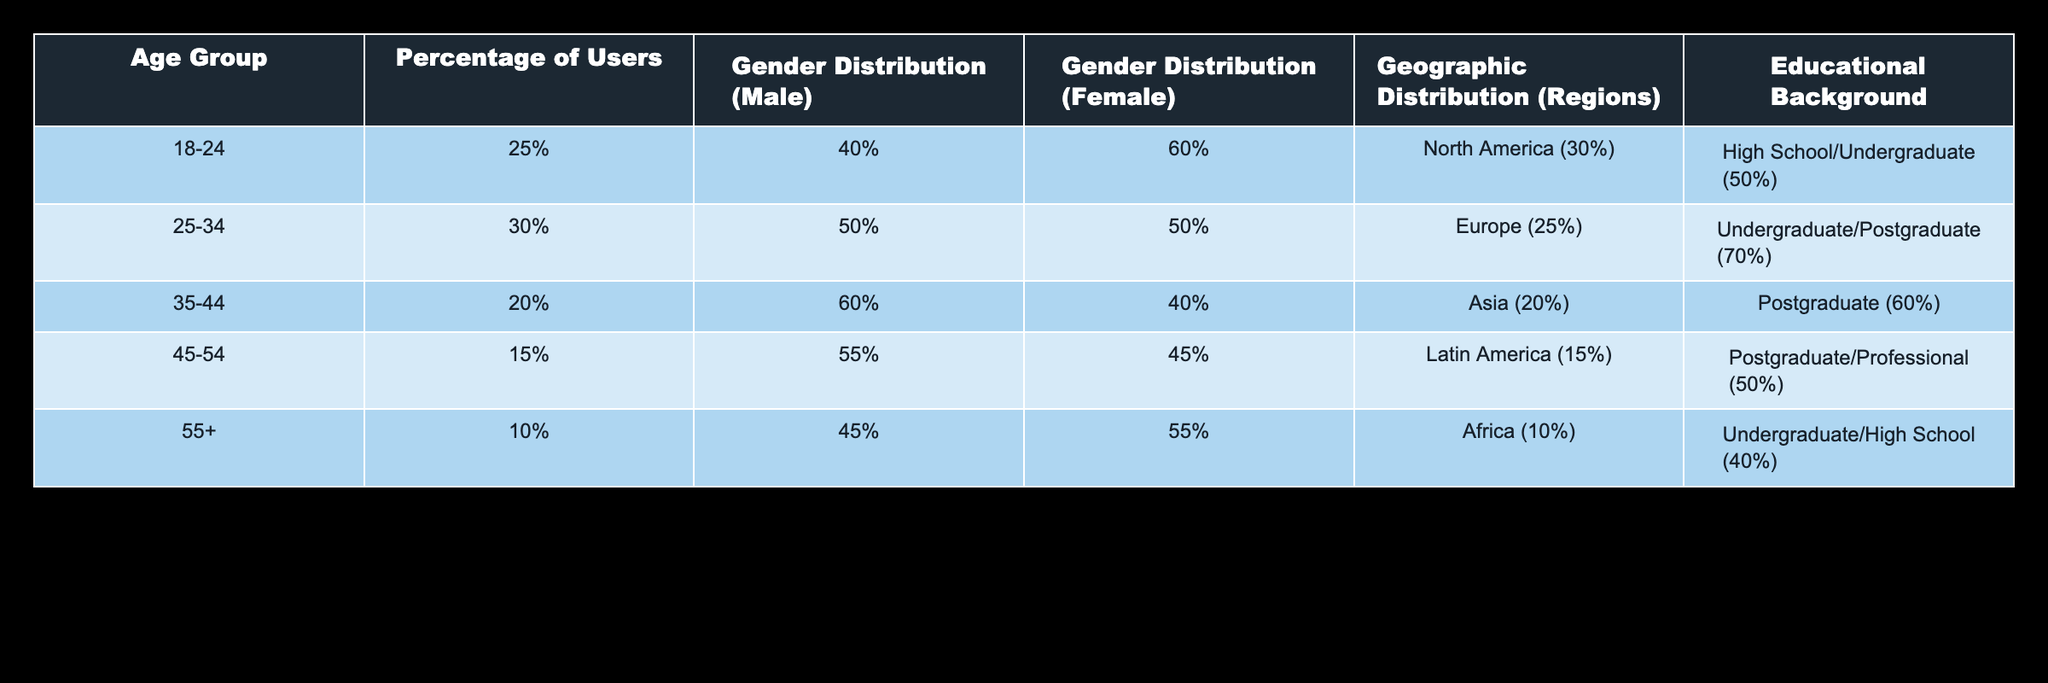What is the percentage of users aged 18-24? The table shows the "Percentage of Users" under the "Age Group" of 18-24 as 25%.
Answer: 25% Which gender has a higher distribution among users aged 45-54? The table lists the "Gender Distribution (Male)" as 55% and "Gender Distribution (Female)" as 45% for users aged 45-54, indicating that males have a higher distribution.
Answer: Male What is the educational background for the age group 35-44? The educational background for the age group 35-44 is listed as "Postgraduate (60%)", meaning that 60% of users in this age group have a postgraduate education.
Answer: Postgraduate Is the percentage of users aged 55+ greater than those aged 35-44? The percentage of users in the 55+ age group is 10%, while the percentage for the 35-44 age group is 20%. Since 10% is less than 20%, it is false that the percentage of users aged 55+ is greater than those aged 35-44.
Answer: No What is the combined percentage of users aged 25-34 and 35-44? The percentage of users 25-34 is 30%, and for 35-44 it is 20%. Adding them together (30 + 20) gives a total of 50%.
Answer: 50% Which geographic region has the highest percentage of users? According to the geographic distribution, North America is noted as having the highest percentage of users at 30%.
Answer: North America Do more users have an undergraduate background or a postgraduate background? For undergraduate backgrounds, the data indicates a total of 50% (18-24: 50%, 25-34: 70%, 55+: 40%). For postgraduate, we have 60% (35-44: 60%, 45-54: 50%). The cumulative percentage for undergraduate users is 50% and for postgraduate, it is 110%. Therefore, more users have a postgraduate background.
Answer: Yes What is the average percentage of male users across all age groups? The percentages of male users are 40% (18-24), 50% (25-34), 60% (35-44), 55% (45-54), and 45% (55+). To find the average, we add them: (40 + 50 + 60 + 55 + 45 = 250) and divide by 5. The average is 250/5 = 50%.
Answer: 50% Which age group has the lowest user percentage? The lowest user percentage is for the age group 55+, which has only 10% of users accessing open educational resources.
Answer: 55+ 